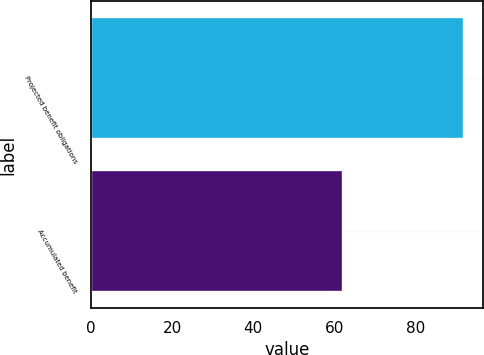<chart> <loc_0><loc_0><loc_500><loc_500><bar_chart><fcel>Projected benefit obligations<fcel>Accumulated benefit<nl><fcel>92<fcel>62<nl></chart> 